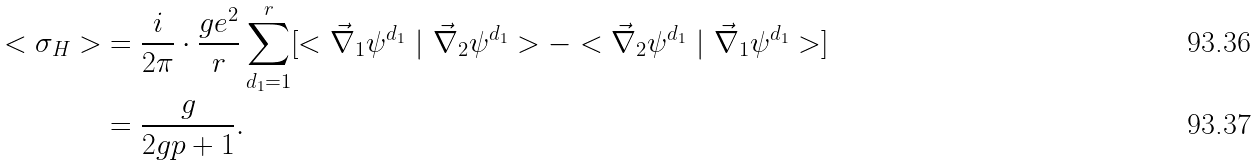Convert formula to latex. <formula><loc_0><loc_0><loc_500><loc_500>< \sigma _ { H } > & = \frac { i } { 2 \pi } \cdot \frac { g e ^ { 2 } } { r } \sum _ { d _ { 1 } = 1 } ^ { r } [ < \vec { \nabla } _ { 1 } \psi ^ { d _ { 1 } } \ | \ \vec { \nabla } _ { 2 } \psi ^ { d _ { 1 } } > - < \vec { \nabla } _ { 2 } \psi ^ { d _ { 1 } } \ | \ \vec { \nabla } _ { 1 } \psi ^ { d _ { 1 } } > ] \\ & = \frac { g } { 2 g p + 1 } .</formula> 